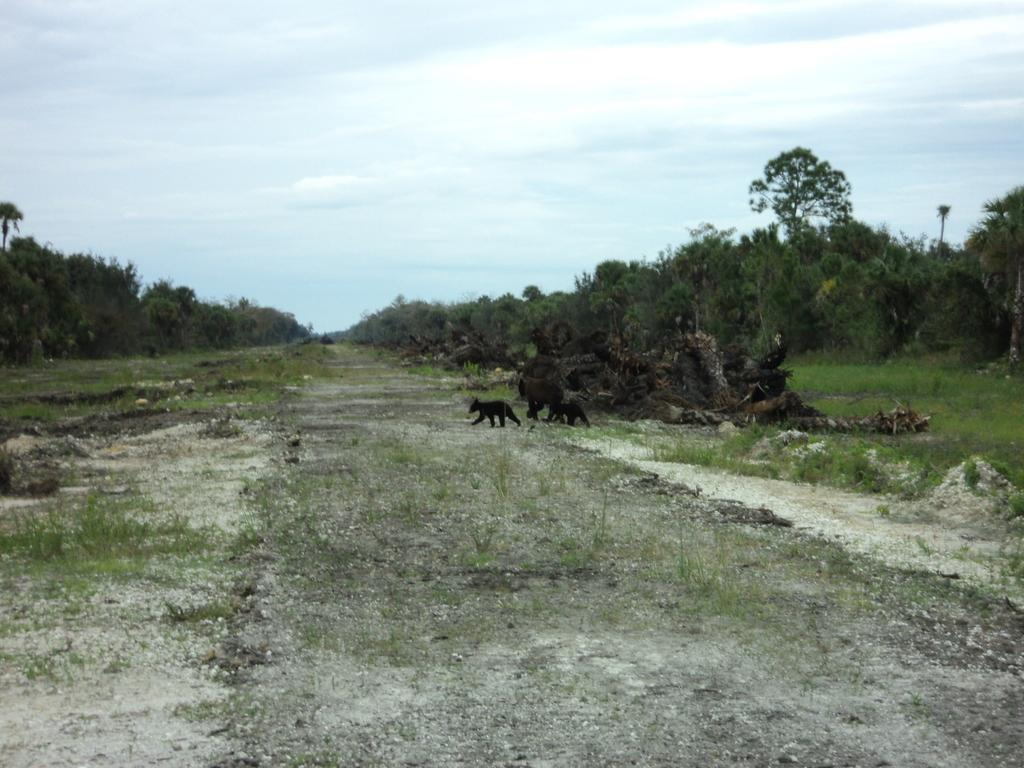What is located in the center of the image? There are animals in the center of the image. What can be seen on the right side of the image? There are logs on the right side of the image. What type of vegetation is visible in the background of the image? There are trees in the background of the image. What is visible in the background of the image besides trees? The sky is visible in the background of the image. What type of ground surface is present at the bottom of the image? There is grass at the bottom of the image. Can you see any chalk being used by the animals in the image? There is no chalk present in the image, and the animals are not using any. What type of wing is visible on the yoke in the image? There is no yoke or wing present in the image. 